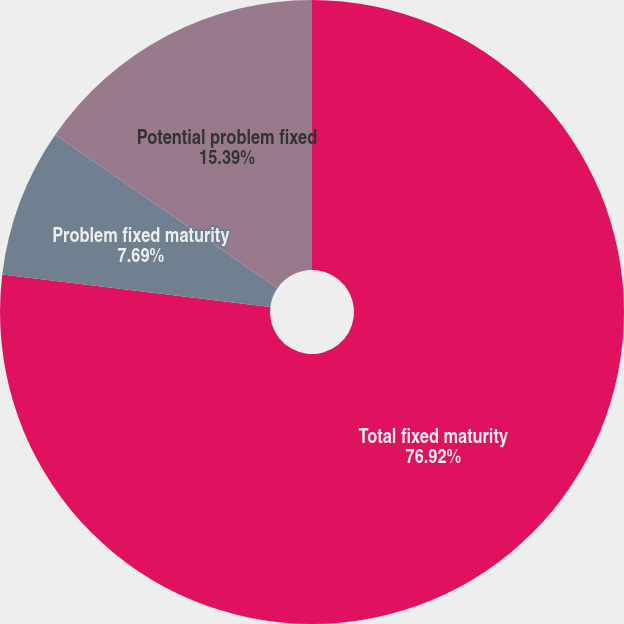<chart> <loc_0><loc_0><loc_500><loc_500><pie_chart><fcel>Total fixed maturity<fcel>Problem fixed maturity<fcel>Potential problem fixed<fcel>Total problem potential<nl><fcel>76.92%<fcel>7.69%<fcel>15.39%<fcel>0.0%<nl></chart> 